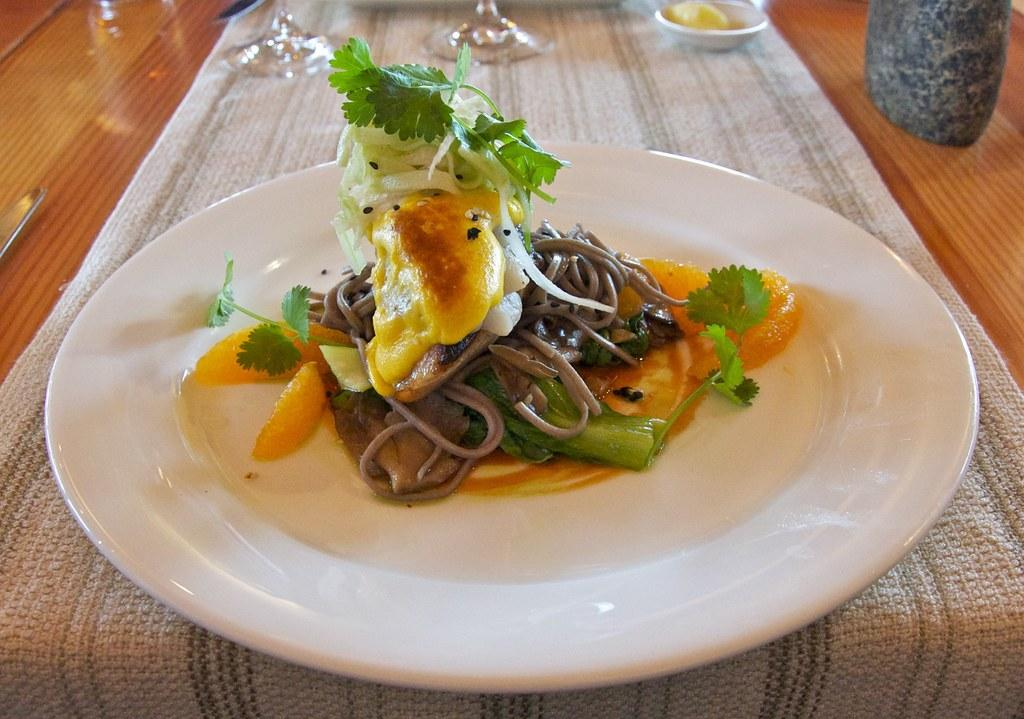What is on the plate that is visible in the image? There is food on a plate in the image. What is placed on the cloth in the image? There are objects on a cloth in the image. What utensil can be seen on the table in the image? There is a knife on the table in the image. What is covering the table in the image? There is a cloth on the table in the image. What else is present on the table in the image? There is an object on the table in the image. What type of voice can be heard coming from the objects on the cloth in the image? There is no voice present in the image; it is a visual representation of objects on a cloth. How many sticks are visible in the image? There are no sticks visible in the image. 